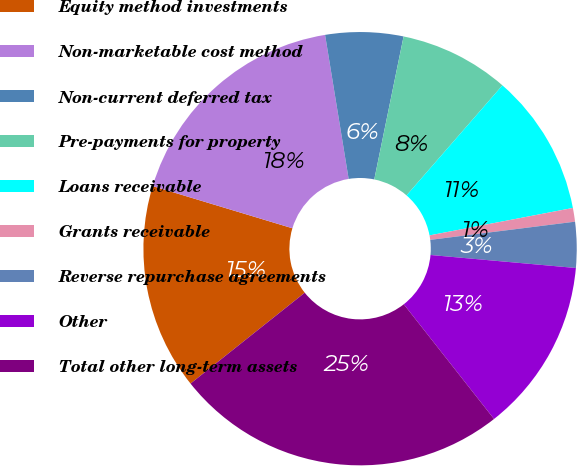Convert chart to OTSL. <chart><loc_0><loc_0><loc_500><loc_500><pie_chart><fcel>Equity method investments<fcel>Non-marketable cost method<fcel>Non-current deferred tax<fcel>Pre-payments for property<fcel>Loans receivable<fcel>Grants receivable<fcel>Reverse repurchase agreements<fcel>Other<fcel>Total other long-term assets<nl><fcel>15.36%<fcel>17.75%<fcel>5.8%<fcel>8.19%<fcel>10.58%<fcel>1.02%<fcel>3.41%<fcel>12.97%<fcel>24.91%<nl></chart> 